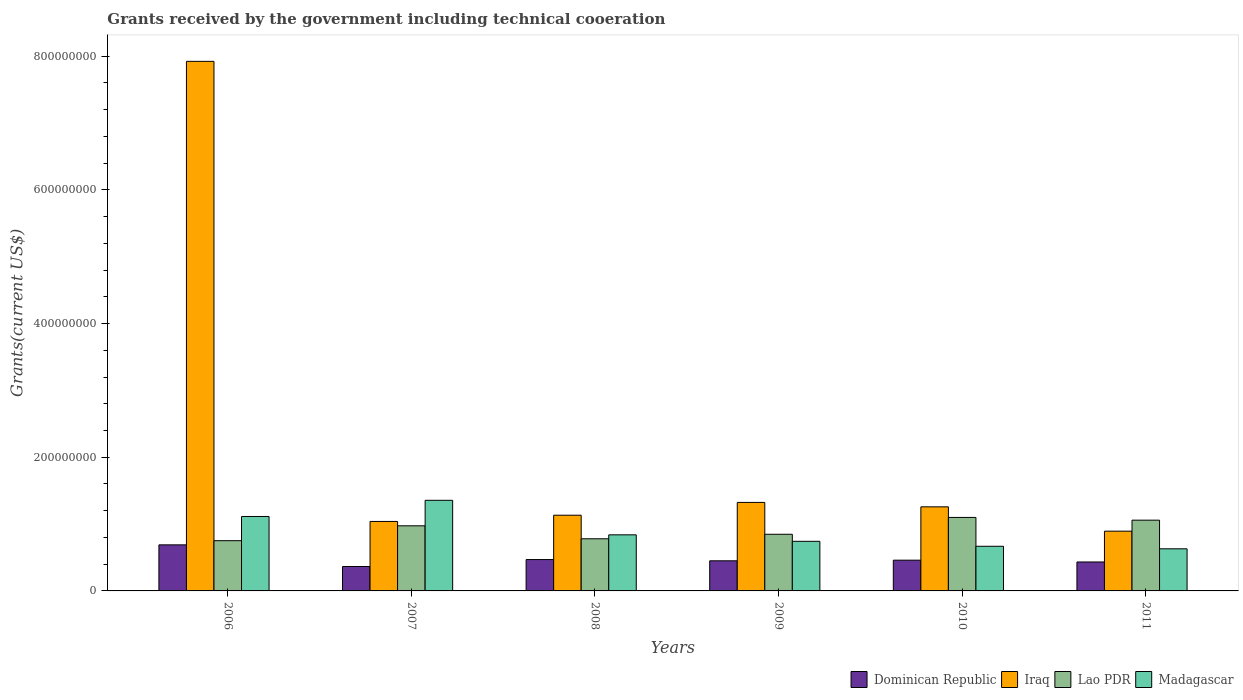How many different coloured bars are there?
Offer a very short reply. 4. Are the number of bars on each tick of the X-axis equal?
Provide a succinct answer. Yes. How many bars are there on the 4th tick from the left?
Your answer should be very brief. 4. What is the total grants received by the government in Lao PDR in 2010?
Your response must be concise. 1.10e+08. Across all years, what is the maximum total grants received by the government in Iraq?
Your answer should be compact. 7.92e+08. Across all years, what is the minimum total grants received by the government in Dominican Republic?
Ensure brevity in your answer.  3.65e+07. In which year was the total grants received by the government in Lao PDR maximum?
Your answer should be very brief. 2010. In which year was the total grants received by the government in Iraq minimum?
Ensure brevity in your answer.  2011. What is the total total grants received by the government in Madagascar in the graph?
Provide a succinct answer. 5.35e+08. What is the difference between the total grants received by the government in Madagascar in 2006 and that in 2009?
Your response must be concise. 3.72e+07. What is the difference between the total grants received by the government in Madagascar in 2011 and the total grants received by the government in Lao PDR in 2007?
Your answer should be very brief. -3.44e+07. What is the average total grants received by the government in Dominican Republic per year?
Provide a short and direct response. 4.78e+07. In the year 2006, what is the difference between the total grants received by the government in Iraq and total grants received by the government in Madagascar?
Ensure brevity in your answer.  6.81e+08. What is the ratio of the total grants received by the government in Lao PDR in 2006 to that in 2007?
Give a very brief answer. 0.77. Is the total grants received by the government in Lao PDR in 2008 less than that in 2009?
Make the answer very short. Yes. What is the difference between the highest and the second highest total grants received by the government in Madagascar?
Provide a short and direct response. 2.42e+07. What is the difference between the highest and the lowest total grants received by the government in Dominican Republic?
Ensure brevity in your answer.  3.24e+07. In how many years, is the total grants received by the government in Lao PDR greater than the average total grants received by the government in Lao PDR taken over all years?
Keep it short and to the point. 3. What does the 2nd bar from the left in 2007 represents?
Give a very brief answer. Iraq. What does the 2nd bar from the right in 2009 represents?
Provide a short and direct response. Lao PDR. Is it the case that in every year, the sum of the total grants received by the government in Lao PDR and total grants received by the government in Dominican Republic is greater than the total grants received by the government in Madagascar?
Ensure brevity in your answer.  No. How many bars are there?
Ensure brevity in your answer.  24. Are all the bars in the graph horizontal?
Provide a short and direct response. No. How many years are there in the graph?
Ensure brevity in your answer.  6. What is the difference between two consecutive major ticks on the Y-axis?
Provide a succinct answer. 2.00e+08. Does the graph contain grids?
Your answer should be very brief. No. Where does the legend appear in the graph?
Provide a succinct answer. Bottom right. What is the title of the graph?
Your answer should be very brief. Grants received by the government including technical cooeration. Does "Portugal" appear as one of the legend labels in the graph?
Your answer should be compact. No. What is the label or title of the X-axis?
Your answer should be compact. Years. What is the label or title of the Y-axis?
Offer a terse response. Grants(current US$). What is the Grants(current US$) of Dominican Republic in 2006?
Your answer should be very brief. 6.89e+07. What is the Grants(current US$) of Iraq in 2006?
Provide a short and direct response. 7.92e+08. What is the Grants(current US$) of Lao PDR in 2006?
Your response must be concise. 7.52e+07. What is the Grants(current US$) in Madagascar in 2006?
Provide a short and direct response. 1.11e+08. What is the Grants(current US$) in Dominican Republic in 2007?
Your response must be concise. 3.65e+07. What is the Grants(current US$) in Iraq in 2007?
Your answer should be very brief. 1.04e+08. What is the Grants(current US$) in Lao PDR in 2007?
Ensure brevity in your answer.  9.74e+07. What is the Grants(current US$) in Madagascar in 2007?
Provide a short and direct response. 1.36e+08. What is the Grants(current US$) in Dominican Republic in 2008?
Offer a very short reply. 4.69e+07. What is the Grants(current US$) in Iraq in 2008?
Make the answer very short. 1.13e+08. What is the Grants(current US$) of Lao PDR in 2008?
Provide a short and direct response. 7.80e+07. What is the Grants(current US$) of Madagascar in 2008?
Make the answer very short. 8.39e+07. What is the Grants(current US$) in Dominican Republic in 2009?
Provide a short and direct response. 4.51e+07. What is the Grants(current US$) in Iraq in 2009?
Your answer should be compact. 1.32e+08. What is the Grants(current US$) of Lao PDR in 2009?
Your answer should be very brief. 8.47e+07. What is the Grants(current US$) in Madagascar in 2009?
Provide a succinct answer. 7.42e+07. What is the Grants(current US$) of Dominican Republic in 2010?
Give a very brief answer. 4.60e+07. What is the Grants(current US$) in Iraq in 2010?
Offer a terse response. 1.26e+08. What is the Grants(current US$) of Lao PDR in 2010?
Keep it short and to the point. 1.10e+08. What is the Grants(current US$) of Madagascar in 2010?
Provide a succinct answer. 6.68e+07. What is the Grants(current US$) of Dominican Republic in 2011?
Your answer should be very brief. 4.33e+07. What is the Grants(current US$) in Iraq in 2011?
Provide a succinct answer. 8.94e+07. What is the Grants(current US$) of Lao PDR in 2011?
Your answer should be compact. 1.06e+08. What is the Grants(current US$) of Madagascar in 2011?
Give a very brief answer. 6.30e+07. Across all years, what is the maximum Grants(current US$) of Dominican Republic?
Give a very brief answer. 6.89e+07. Across all years, what is the maximum Grants(current US$) in Iraq?
Provide a short and direct response. 7.92e+08. Across all years, what is the maximum Grants(current US$) of Lao PDR?
Your answer should be very brief. 1.10e+08. Across all years, what is the maximum Grants(current US$) in Madagascar?
Provide a short and direct response. 1.36e+08. Across all years, what is the minimum Grants(current US$) of Dominican Republic?
Provide a short and direct response. 3.65e+07. Across all years, what is the minimum Grants(current US$) of Iraq?
Your answer should be very brief. 8.94e+07. Across all years, what is the minimum Grants(current US$) in Lao PDR?
Make the answer very short. 7.52e+07. Across all years, what is the minimum Grants(current US$) in Madagascar?
Offer a terse response. 6.30e+07. What is the total Grants(current US$) in Dominican Republic in the graph?
Your answer should be compact. 2.87e+08. What is the total Grants(current US$) in Iraq in the graph?
Offer a very short reply. 1.36e+09. What is the total Grants(current US$) in Lao PDR in the graph?
Ensure brevity in your answer.  5.51e+08. What is the total Grants(current US$) of Madagascar in the graph?
Your answer should be very brief. 5.35e+08. What is the difference between the Grants(current US$) of Dominican Republic in 2006 and that in 2007?
Your answer should be very brief. 3.24e+07. What is the difference between the Grants(current US$) of Iraq in 2006 and that in 2007?
Provide a succinct answer. 6.88e+08. What is the difference between the Grants(current US$) in Lao PDR in 2006 and that in 2007?
Your answer should be very brief. -2.22e+07. What is the difference between the Grants(current US$) of Madagascar in 2006 and that in 2007?
Give a very brief answer. -2.42e+07. What is the difference between the Grants(current US$) of Dominican Republic in 2006 and that in 2008?
Offer a very short reply. 2.20e+07. What is the difference between the Grants(current US$) in Iraq in 2006 and that in 2008?
Offer a very short reply. 6.79e+08. What is the difference between the Grants(current US$) in Lao PDR in 2006 and that in 2008?
Make the answer very short. -2.86e+06. What is the difference between the Grants(current US$) in Madagascar in 2006 and that in 2008?
Your answer should be compact. 2.75e+07. What is the difference between the Grants(current US$) in Dominican Republic in 2006 and that in 2009?
Your answer should be very brief. 2.38e+07. What is the difference between the Grants(current US$) of Iraq in 2006 and that in 2009?
Offer a very short reply. 6.60e+08. What is the difference between the Grants(current US$) of Lao PDR in 2006 and that in 2009?
Make the answer very short. -9.57e+06. What is the difference between the Grants(current US$) of Madagascar in 2006 and that in 2009?
Your response must be concise. 3.72e+07. What is the difference between the Grants(current US$) of Dominican Republic in 2006 and that in 2010?
Make the answer very short. 2.29e+07. What is the difference between the Grants(current US$) in Iraq in 2006 and that in 2010?
Keep it short and to the point. 6.66e+08. What is the difference between the Grants(current US$) of Lao PDR in 2006 and that in 2010?
Keep it short and to the point. -3.48e+07. What is the difference between the Grants(current US$) of Madagascar in 2006 and that in 2010?
Provide a succinct answer. 4.46e+07. What is the difference between the Grants(current US$) of Dominican Republic in 2006 and that in 2011?
Provide a short and direct response. 2.56e+07. What is the difference between the Grants(current US$) of Iraq in 2006 and that in 2011?
Offer a terse response. 7.03e+08. What is the difference between the Grants(current US$) in Lao PDR in 2006 and that in 2011?
Provide a short and direct response. -3.07e+07. What is the difference between the Grants(current US$) in Madagascar in 2006 and that in 2011?
Your response must be concise. 4.84e+07. What is the difference between the Grants(current US$) of Dominican Republic in 2007 and that in 2008?
Offer a very short reply. -1.04e+07. What is the difference between the Grants(current US$) of Iraq in 2007 and that in 2008?
Offer a very short reply. -9.33e+06. What is the difference between the Grants(current US$) in Lao PDR in 2007 and that in 2008?
Make the answer very short. 1.94e+07. What is the difference between the Grants(current US$) of Madagascar in 2007 and that in 2008?
Provide a succinct answer. 5.17e+07. What is the difference between the Grants(current US$) of Dominican Republic in 2007 and that in 2009?
Your answer should be very brief. -8.54e+06. What is the difference between the Grants(current US$) of Iraq in 2007 and that in 2009?
Offer a very short reply. -2.85e+07. What is the difference between the Grants(current US$) of Lao PDR in 2007 and that in 2009?
Provide a short and direct response. 1.27e+07. What is the difference between the Grants(current US$) of Madagascar in 2007 and that in 2009?
Make the answer very short. 6.14e+07. What is the difference between the Grants(current US$) of Dominican Republic in 2007 and that in 2010?
Offer a terse response. -9.47e+06. What is the difference between the Grants(current US$) of Iraq in 2007 and that in 2010?
Give a very brief answer. -2.19e+07. What is the difference between the Grants(current US$) in Lao PDR in 2007 and that in 2010?
Your answer should be compact. -1.26e+07. What is the difference between the Grants(current US$) in Madagascar in 2007 and that in 2010?
Give a very brief answer. 6.88e+07. What is the difference between the Grants(current US$) of Dominican Republic in 2007 and that in 2011?
Offer a very short reply. -6.79e+06. What is the difference between the Grants(current US$) of Iraq in 2007 and that in 2011?
Your response must be concise. 1.45e+07. What is the difference between the Grants(current US$) of Lao PDR in 2007 and that in 2011?
Give a very brief answer. -8.46e+06. What is the difference between the Grants(current US$) of Madagascar in 2007 and that in 2011?
Offer a very short reply. 7.26e+07. What is the difference between the Grants(current US$) of Dominican Republic in 2008 and that in 2009?
Provide a short and direct response. 1.86e+06. What is the difference between the Grants(current US$) in Iraq in 2008 and that in 2009?
Provide a short and direct response. -1.92e+07. What is the difference between the Grants(current US$) of Lao PDR in 2008 and that in 2009?
Give a very brief answer. -6.71e+06. What is the difference between the Grants(current US$) of Madagascar in 2008 and that in 2009?
Your answer should be compact. 9.69e+06. What is the difference between the Grants(current US$) of Dominican Republic in 2008 and that in 2010?
Offer a terse response. 9.30e+05. What is the difference between the Grants(current US$) in Iraq in 2008 and that in 2010?
Your response must be concise. -1.25e+07. What is the difference between the Grants(current US$) of Lao PDR in 2008 and that in 2010?
Your answer should be compact. -3.19e+07. What is the difference between the Grants(current US$) of Madagascar in 2008 and that in 2010?
Your answer should be compact. 1.71e+07. What is the difference between the Grants(current US$) of Dominican Republic in 2008 and that in 2011?
Provide a succinct answer. 3.61e+06. What is the difference between the Grants(current US$) in Iraq in 2008 and that in 2011?
Ensure brevity in your answer.  2.38e+07. What is the difference between the Grants(current US$) in Lao PDR in 2008 and that in 2011?
Give a very brief answer. -2.78e+07. What is the difference between the Grants(current US$) of Madagascar in 2008 and that in 2011?
Offer a terse response. 2.09e+07. What is the difference between the Grants(current US$) in Dominican Republic in 2009 and that in 2010?
Make the answer very short. -9.30e+05. What is the difference between the Grants(current US$) in Iraq in 2009 and that in 2010?
Offer a very short reply. 6.61e+06. What is the difference between the Grants(current US$) in Lao PDR in 2009 and that in 2010?
Provide a succinct answer. -2.52e+07. What is the difference between the Grants(current US$) in Madagascar in 2009 and that in 2010?
Provide a succinct answer. 7.41e+06. What is the difference between the Grants(current US$) in Dominican Republic in 2009 and that in 2011?
Your response must be concise. 1.75e+06. What is the difference between the Grants(current US$) of Iraq in 2009 and that in 2011?
Provide a succinct answer. 4.30e+07. What is the difference between the Grants(current US$) in Lao PDR in 2009 and that in 2011?
Ensure brevity in your answer.  -2.11e+07. What is the difference between the Grants(current US$) of Madagascar in 2009 and that in 2011?
Keep it short and to the point. 1.12e+07. What is the difference between the Grants(current US$) in Dominican Republic in 2010 and that in 2011?
Give a very brief answer. 2.68e+06. What is the difference between the Grants(current US$) in Iraq in 2010 and that in 2011?
Your answer should be very brief. 3.64e+07. What is the difference between the Grants(current US$) of Lao PDR in 2010 and that in 2011?
Offer a terse response. 4.09e+06. What is the difference between the Grants(current US$) in Madagascar in 2010 and that in 2011?
Provide a short and direct response. 3.79e+06. What is the difference between the Grants(current US$) in Dominican Republic in 2006 and the Grants(current US$) in Iraq in 2007?
Offer a terse response. -3.50e+07. What is the difference between the Grants(current US$) of Dominican Republic in 2006 and the Grants(current US$) of Lao PDR in 2007?
Your answer should be compact. -2.85e+07. What is the difference between the Grants(current US$) in Dominican Republic in 2006 and the Grants(current US$) in Madagascar in 2007?
Give a very brief answer. -6.66e+07. What is the difference between the Grants(current US$) in Iraq in 2006 and the Grants(current US$) in Lao PDR in 2007?
Make the answer very short. 6.95e+08. What is the difference between the Grants(current US$) in Iraq in 2006 and the Grants(current US$) in Madagascar in 2007?
Your response must be concise. 6.57e+08. What is the difference between the Grants(current US$) in Lao PDR in 2006 and the Grants(current US$) in Madagascar in 2007?
Your answer should be very brief. -6.04e+07. What is the difference between the Grants(current US$) of Dominican Republic in 2006 and the Grants(current US$) of Iraq in 2008?
Provide a succinct answer. -4.43e+07. What is the difference between the Grants(current US$) in Dominican Republic in 2006 and the Grants(current US$) in Lao PDR in 2008?
Your response must be concise. -9.11e+06. What is the difference between the Grants(current US$) of Dominican Republic in 2006 and the Grants(current US$) of Madagascar in 2008?
Make the answer very short. -1.50e+07. What is the difference between the Grants(current US$) in Iraq in 2006 and the Grants(current US$) in Lao PDR in 2008?
Offer a terse response. 7.14e+08. What is the difference between the Grants(current US$) in Iraq in 2006 and the Grants(current US$) in Madagascar in 2008?
Provide a succinct answer. 7.08e+08. What is the difference between the Grants(current US$) in Lao PDR in 2006 and the Grants(current US$) in Madagascar in 2008?
Make the answer very short. -8.73e+06. What is the difference between the Grants(current US$) in Dominican Republic in 2006 and the Grants(current US$) in Iraq in 2009?
Offer a very short reply. -6.35e+07. What is the difference between the Grants(current US$) of Dominican Republic in 2006 and the Grants(current US$) of Lao PDR in 2009?
Your answer should be very brief. -1.58e+07. What is the difference between the Grants(current US$) of Dominican Republic in 2006 and the Grants(current US$) of Madagascar in 2009?
Offer a terse response. -5.29e+06. What is the difference between the Grants(current US$) of Iraq in 2006 and the Grants(current US$) of Lao PDR in 2009?
Keep it short and to the point. 7.07e+08. What is the difference between the Grants(current US$) in Iraq in 2006 and the Grants(current US$) in Madagascar in 2009?
Your response must be concise. 7.18e+08. What is the difference between the Grants(current US$) in Lao PDR in 2006 and the Grants(current US$) in Madagascar in 2009?
Your answer should be compact. 9.60e+05. What is the difference between the Grants(current US$) in Dominican Republic in 2006 and the Grants(current US$) in Iraq in 2010?
Your response must be concise. -5.69e+07. What is the difference between the Grants(current US$) in Dominican Republic in 2006 and the Grants(current US$) in Lao PDR in 2010?
Give a very brief answer. -4.10e+07. What is the difference between the Grants(current US$) in Dominican Republic in 2006 and the Grants(current US$) in Madagascar in 2010?
Offer a terse response. 2.12e+06. What is the difference between the Grants(current US$) of Iraq in 2006 and the Grants(current US$) of Lao PDR in 2010?
Your answer should be very brief. 6.82e+08. What is the difference between the Grants(current US$) of Iraq in 2006 and the Grants(current US$) of Madagascar in 2010?
Your response must be concise. 7.25e+08. What is the difference between the Grants(current US$) in Lao PDR in 2006 and the Grants(current US$) in Madagascar in 2010?
Your answer should be compact. 8.37e+06. What is the difference between the Grants(current US$) in Dominican Republic in 2006 and the Grants(current US$) in Iraq in 2011?
Provide a succinct answer. -2.05e+07. What is the difference between the Grants(current US$) in Dominican Republic in 2006 and the Grants(current US$) in Lao PDR in 2011?
Your response must be concise. -3.70e+07. What is the difference between the Grants(current US$) of Dominican Republic in 2006 and the Grants(current US$) of Madagascar in 2011?
Ensure brevity in your answer.  5.91e+06. What is the difference between the Grants(current US$) in Iraq in 2006 and the Grants(current US$) in Lao PDR in 2011?
Give a very brief answer. 6.86e+08. What is the difference between the Grants(current US$) in Iraq in 2006 and the Grants(current US$) in Madagascar in 2011?
Give a very brief answer. 7.29e+08. What is the difference between the Grants(current US$) in Lao PDR in 2006 and the Grants(current US$) in Madagascar in 2011?
Offer a terse response. 1.22e+07. What is the difference between the Grants(current US$) in Dominican Republic in 2007 and the Grants(current US$) in Iraq in 2008?
Keep it short and to the point. -7.67e+07. What is the difference between the Grants(current US$) in Dominican Republic in 2007 and the Grants(current US$) in Lao PDR in 2008?
Give a very brief answer. -4.15e+07. What is the difference between the Grants(current US$) of Dominican Republic in 2007 and the Grants(current US$) of Madagascar in 2008?
Provide a succinct answer. -4.74e+07. What is the difference between the Grants(current US$) in Iraq in 2007 and the Grants(current US$) in Lao PDR in 2008?
Provide a succinct answer. 2.59e+07. What is the difference between the Grants(current US$) of Iraq in 2007 and the Grants(current US$) of Madagascar in 2008?
Make the answer very short. 2.00e+07. What is the difference between the Grants(current US$) in Lao PDR in 2007 and the Grants(current US$) in Madagascar in 2008?
Give a very brief answer. 1.35e+07. What is the difference between the Grants(current US$) of Dominican Republic in 2007 and the Grants(current US$) of Iraq in 2009?
Make the answer very short. -9.59e+07. What is the difference between the Grants(current US$) of Dominican Republic in 2007 and the Grants(current US$) of Lao PDR in 2009?
Your response must be concise. -4.82e+07. What is the difference between the Grants(current US$) of Dominican Republic in 2007 and the Grants(current US$) of Madagascar in 2009?
Your answer should be compact. -3.77e+07. What is the difference between the Grants(current US$) in Iraq in 2007 and the Grants(current US$) in Lao PDR in 2009?
Your answer should be compact. 1.92e+07. What is the difference between the Grants(current US$) of Iraq in 2007 and the Grants(current US$) of Madagascar in 2009?
Make the answer very short. 2.97e+07. What is the difference between the Grants(current US$) of Lao PDR in 2007 and the Grants(current US$) of Madagascar in 2009?
Offer a terse response. 2.32e+07. What is the difference between the Grants(current US$) of Dominican Republic in 2007 and the Grants(current US$) of Iraq in 2010?
Provide a short and direct response. -8.93e+07. What is the difference between the Grants(current US$) in Dominican Republic in 2007 and the Grants(current US$) in Lao PDR in 2010?
Keep it short and to the point. -7.34e+07. What is the difference between the Grants(current US$) in Dominican Republic in 2007 and the Grants(current US$) in Madagascar in 2010?
Offer a terse response. -3.03e+07. What is the difference between the Grants(current US$) of Iraq in 2007 and the Grants(current US$) of Lao PDR in 2010?
Your answer should be very brief. -6.03e+06. What is the difference between the Grants(current US$) of Iraq in 2007 and the Grants(current US$) of Madagascar in 2010?
Keep it short and to the point. 3.71e+07. What is the difference between the Grants(current US$) of Lao PDR in 2007 and the Grants(current US$) of Madagascar in 2010?
Provide a succinct answer. 3.06e+07. What is the difference between the Grants(current US$) in Dominican Republic in 2007 and the Grants(current US$) in Iraq in 2011?
Give a very brief answer. -5.29e+07. What is the difference between the Grants(current US$) of Dominican Republic in 2007 and the Grants(current US$) of Lao PDR in 2011?
Make the answer very short. -6.93e+07. What is the difference between the Grants(current US$) in Dominican Republic in 2007 and the Grants(current US$) in Madagascar in 2011?
Your answer should be compact. -2.65e+07. What is the difference between the Grants(current US$) in Iraq in 2007 and the Grants(current US$) in Lao PDR in 2011?
Offer a very short reply. -1.94e+06. What is the difference between the Grants(current US$) of Iraq in 2007 and the Grants(current US$) of Madagascar in 2011?
Make the answer very short. 4.09e+07. What is the difference between the Grants(current US$) of Lao PDR in 2007 and the Grants(current US$) of Madagascar in 2011?
Your response must be concise. 3.44e+07. What is the difference between the Grants(current US$) in Dominican Republic in 2008 and the Grants(current US$) in Iraq in 2009?
Make the answer very short. -8.55e+07. What is the difference between the Grants(current US$) in Dominican Republic in 2008 and the Grants(current US$) in Lao PDR in 2009?
Provide a succinct answer. -3.78e+07. What is the difference between the Grants(current US$) of Dominican Republic in 2008 and the Grants(current US$) of Madagascar in 2009?
Give a very brief answer. -2.73e+07. What is the difference between the Grants(current US$) of Iraq in 2008 and the Grants(current US$) of Lao PDR in 2009?
Give a very brief answer. 2.85e+07. What is the difference between the Grants(current US$) of Iraq in 2008 and the Grants(current US$) of Madagascar in 2009?
Provide a succinct answer. 3.90e+07. What is the difference between the Grants(current US$) in Lao PDR in 2008 and the Grants(current US$) in Madagascar in 2009?
Give a very brief answer. 3.82e+06. What is the difference between the Grants(current US$) in Dominican Republic in 2008 and the Grants(current US$) in Iraq in 2010?
Your answer should be very brief. -7.89e+07. What is the difference between the Grants(current US$) of Dominican Republic in 2008 and the Grants(current US$) of Lao PDR in 2010?
Offer a terse response. -6.30e+07. What is the difference between the Grants(current US$) in Dominican Republic in 2008 and the Grants(current US$) in Madagascar in 2010?
Your response must be concise. -1.99e+07. What is the difference between the Grants(current US$) of Iraq in 2008 and the Grants(current US$) of Lao PDR in 2010?
Make the answer very short. 3.30e+06. What is the difference between the Grants(current US$) in Iraq in 2008 and the Grants(current US$) in Madagascar in 2010?
Your response must be concise. 4.65e+07. What is the difference between the Grants(current US$) of Lao PDR in 2008 and the Grants(current US$) of Madagascar in 2010?
Your response must be concise. 1.12e+07. What is the difference between the Grants(current US$) of Dominican Republic in 2008 and the Grants(current US$) of Iraq in 2011?
Offer a terse response. -4.25e+07. What is the difference between the Grants(current US$) of Dominican Republic in 2008 and the Grants(current US$) of Lao PDR in 2011?
Your response must be concise. -5.89e+07. What is the difference between the Grants(current US$) in Dominican Republic in 2008 and the Grants(current US$) in Madagascar in 2011?
Give a very brief answer. -1.61e+07. What is the difference between the Grants(current US$) in Iraq in 2008 and the Grants(current US$) in Lao PDR in 2011?
Offer a very short reply. 7.39e+06. What is the difference between the Grants(current US$) of Iraq in 2008 and the Grants(current US$) of Madagascar in 2011?
Your answer should be compact. 5.02e+07. What is the difference between the Grants(current US$) of Lao PDR in 2008 and the Grants(current US$) of Madagascar in 2011?
Keep it short and to the point. 1.50e+07. What is the difference between the Grants(current US$) of Dominican Republic in 2009 and the Grants(current US$) of Iraq in 2010?
Your answer should be compact. -8.07e+07. What is the difference between the Grants(current US$) of Dominican Republic in 2009 and the Grants(current US$) of Lao PDR in 2010?
Your answer should be compact. -6.49e+07. What is the difference between the Grants(current US$) in Dominican Republic in 2009 and the Grants(current US$) in Madagascar in 2010?
Make the answer very short. -2.17e+07. What is the difference between the Grants(current US$) in Iraq in 2009 and the Grants(current US$) in Lao PDR in 2010?
Offer a terse response. 2.24e+07. What is the difference between the Grants(current US$) in Iraq in 2009 and the Grants(current US$) in Madagascar in 2010?
Offer a terse response. 6.56e+07. What is the difference between the Grants(current US$) of Lao PDR in 2009 and the Grants(current US$) of Madagascar in 2010?
Offer a very short reply. 1.79e+07. What is the difference between the Grants(current US$) of Dominican Republic in 2009 and the Grants(current US$) of Iraq in 2011?
Offer a terse response. -4.43e+07. What is the difference between the Grants(current US$) of Dominican Republic in 2009 and the Grants(current US$) of Lao PDR in 2011?
Your answer should be compact. -6.08e+07. What is the difference between the Grants(current US$) in Dominican Republic in 2009 and the Grants(current US$) in Madagascar in 2011?
Offer a terse response. -1.79e+07. What is the difference between the Grants(current US$) in Iraq in 2009 and the Grants(current US$) in Lao PDR in 2011?
Your response must be concise. 2.65e+07. What is the difference between the Grants(current US$) in Iraq in 2009 and the Grants(current US$) in Madagascar in 2011?
Give a very brief answer. 6.94e+07. What is the difference between the Grants(current US$) in Lao PDR in 2009 and the Grants(current US$) in Madagascar in 2011?
Your answer should be very brief. 2.17e+07. What is the difference between the Grants(current US$) of Dominican Republic in 2010 and the Grants(current US$) of Iraq in 2011?
Give a very brief answer. -4.34e+07. What is the difference between the Grants(current US$) in Dominican Republic in 2010 and the Grants(current US$) in Lao PDR in 2011?
Make the answer very short. -5.99e+07. What is the difference between the Grants(current US$) of Dominican Republic in 2010 and the Grants(current US$) of Madagascar in 2011?
Provide a short and direct response. -1.70e+07. What is the difference between the Grants(current US$) in Iraq in 2010 and the Grants(current US$) in Lao PDR in 2011?
Make the answer very short. 1.99e+07. What is the difference between the Grants(current US$) in Iraq in 2010 and the Grants(current US$) in Madagascar in 2011?
Keep it short and to the point. 6.28e+07. What is the difference between the Grants(current US$) in Lao PDR in 2010 and the Grants(current US$) in Madagascar in 2011?
Your answer should be very brief. 4.70e+07. What is the average Grants(current US$) of Dominican Republic per year?
Keep it short and to the point. 4.78e+07. What is the average Grants(current US$) of Iraq per year?
Offer a terse response. 2.26e+08. What is the average Grants(current US$) of Lao PDR per year?
Your answer should be compact. 9.19e+07. What is the average Grants(current US$) of Madagascar per year?
Your response must be concise. 8.91e+07. In the year 2006, what is the difference between the Grants(current US$) in Dominican Republic and Grants(current US$) in Iraq?
Provide a short and direct response. -7.23e+08. In the year 2006, what is the difference between the Grants(current US$) in Dominican Republic and Grants(current US$) in Lao PDR?
Provide a succinct answer. -6.25e+06. In the year 2006, what is the difference between the Grants(current US$) in Dominican Republic and Grants(current US$) in Madagascar?
Your response must be concise. -4.25e+07. In the year 2006, what is the difference between the Grants(current US$) of Iraq and Grants(current US$) of Lao PDR?
Your answer should be very brief. 7.17e+08. In the year 2006, what is the difference between the Grants(current US$) in Iraq and Grants(current US$) in Madagascar?
Provide a short and direct response. 6.81e+08. In the year 2006, what is the difference between the Grants(current US$) in Lao PDR and Grants(current US$) in Madagascar?
Keep it short and to the point. -3.62e+07. In the year 2007, what is the difference between the Grants(current US$) in Dominican Republic and Grants(current US$) in Iraq?
Keep it short and to the point. -6.74e+07. In the year 2007, what is the difference between the Grants(current US$) of Dominican Republic and Grants(current US$) of Lao PDR?
Provide a succinct answer. -6.09e+07. In the year 2007, what is the difference between the Grants(current US$) of Dominican Republic and Grants(current US$) of Madagascar?
Offer a very short reply. -9.90e+07. In the year 2007, what is the difference between the Grants(current US$) of Iraq and Grants(current US$) of Lao PDR?
Your response must be concise. 6.52e+06. In the year 2007, what is the difference between the Grants(current US$) in Iraq and Grants(current US$) in Madagascar?
Provide a short and direct response. -3.16e+07. In the year 2007, what is the difference between the Grants(current US$) of Lao PDR and Grants(current US$) of Madagascar?
Ensure brevity in your answer.  -3.82e+07. In the year 2008, what is the difference between the Grants(current US$) in Dominican Republic and Grants(current US$) in Iraq?
Your response must be concise. -6.63e+07. In the year 2008, what is the difference between the Grants(current US$) of Dominican Republic and Grants(current US$) of Lao PDR?
Ensure brevity in your answer.  -3.11e+07. In the year 2008, what is the difference between the Grants(current US$) of Dominican Republic and Grants(current US$) of Madagascar?
Ensure brevity in your answer.  -3.70e+07. In the year 2008, what is the difference between the Grants(current US$) in Iraq and Grants(current US$) in Lao PDR?
Provide a succinct answer. 3.52e+07. In the year 2008, what is the difference between the Grants(current US$) in Iraq and Grants(current US$) in Madagascar?
Provide a succinct answer. 2.94e+07. In the year 2008, what is the difference between the Grants(current US$) in Lao PDR and Grants(current US$) in Madagascar?
Your answer should be compact. -5.87e+06. In the year 2009, what is the difference between the Grants(current US$) in Dominican Republic and Grants(current US$) in Iraq?
Provide a short and direct response. -8.73e+07. In the year 2009, what is the difference between the Grants(current US$) of Dominican Republic and Grants(current US$) of Lao PDR?
Offer a very short reply. -3.97e+07. In the year 2009, what is the difference between the Grants(current US$) in Dominican Republic and Grants(current US$) in Madagascar?
Give a very brief answer. -2.91e+07. In the year 2009, what is the difference between the Grants(current US$) in Iraq and Grants(current US$) in Lao PDR?
Provide a short and direct response. 4.77e+07. In the year 2009, what is the difference between the Grants(current US$) of Iraq and Grants(current US$) of Madagascar?
Make the answer very short. 5.82e+07. In the year 2009, what is the difference between the Grants(current US$) in Lao PDR and Grants(current US$) in Madagascar?
Provide a short and direct response. 1.05e+07. In the year 2010, what is the difference between the Grants(current US$) of Dominican Republic and Grants(current US$) of Iraq?
Your response must be concise. -7.98e+07. In the year 2010, what is the difference between the Grants(current US$) of Dominican Republic and Grants(current US$) of Lao PDR?
Make the answer very short. -6.40e+07. In the year 2010, what is the difference between the Grants(current US$) in Dominican Republic and Grants(current US$) in Madagascar?
Provide a short and direct response. -2.08e+07. In the year 2010, what is the difference between the Grants(current US$) of Iraq and Grants(current US$) of Lao PDR?
Your answer should be very brief. 1.58e+07. In the year 2010, what is the difference between the Grants(current US$) in Iraq and Grants(current US$) in Madagascar?
Offer a very short reply. 5.90e+07. In the year 2010, what is the difference between the Grants(current US$) in Lao PDR and Grants(current US$) in Madagascar?
Provide a succinct answer. 4.32e+07. In the year 2011, what is the difference between the Grants(current US$) in Dominican Republic and Grants(current US$) in Iraq?
Your answer should be compact. -4.61e+07. In the year 2011, what is the difference between the Grants(current US$) of Dominican Republic and Grants(current US$) of Lao PDR?
Your answer should be very brief. -6.26e+07. In the year 2011, what is the difference between the Grants(current US$) of Dominican Republic and Grants(current US$) of Madagascar?
Give a very brief answer. -1.97e+07. In the year 2011, what is the difference between the Grants(current US$) of Iraq and Grants(current US$) of Lao PDR?
Offer a terse response. -1.65e+07. In the year 2011, what is the difference between the Grants(current US$) in Iraq and Grants(current US$) in Madagascar?
Keep it short and to the point. 2.64e+07. In the year 2011, what is the difference between the Grants(current US$) in Lao PDR and Grants(current US$) in Madagascar?
Provide a short and direct response. 4.29e+07. What is the ratio of the Grants(current US$) of Dominican Republic in 2006 to that in 2007?
Offer a very short reply. 1.89. What is the ratio of the Grants(current US$) in Iraq in 2006 to that in 2007?
Your answer should be very brief. 7.62. What is the ratio of the Grants(current US$) of Lao PDR in 2006 to that in 2007?
Your response must be concise. 0.77. What is the ratio of the Grants(current US$) in Madagascar in 2006 to that in 2007?
Your answer should be compact. 0.82. What is the ratio of the Grants(current US$) of Dominican Republic in 2006 to that in 2008?
Your response must be concise. 1.47. What is the ratio of the Grants(current US$) in Iraq in 2006 to that in 2008?
Offer a very short reply. 7. What is the ratio of the Grants(current US$) in Lao PDR in 2006 to that in 2008?
Give a very brief answer. 0.96. What is the ratio of the Grants(current US$) of Madagascar in 2006 to that in 2008?
Provide a succinct answer. 1.33. What is the ratio of the Grants(current US$) of Dominican Republic in 2006 to that in 2009?
Your answer should be very brief. 1.53. What is the ratio of the Grants(current US$) of Iraq in 2006 to that in 2009?
Your answer should be compact. 5.98. What is the ratio of the Grants(current US$) of Lao PDR in 2006 to that in 2009?
Make the answer very short. 0.89. What is the ratio of the Grants(current US$) in Madagascar in 2006 to that in 2009?
Offer a very short reply. 1.5. What is the ratio of the Grants(current US$) in Dominican Republic in 2006 to that in 2010?
Offer a terse response. 1.5. What is the ratio of the Grants(current US$) of Iraq in 2006 to that in 2010?
Keep it short and to the point. 6.3. What is the ratio of the Grants(current US$) in Lao PDR in 2006 to that in 2010?
Your answer should be very brief. 0.68. What is the ratio of the Grants(current US$) of Madagascar in 2006 to that in 2010?
Your response must be concise. 1.67. What is the ratio of the Grants(current US$) in Dominican Republic in 2006 to that in 2011?
Offer a terse response. 1.59. What is the ratio of the Grants(current US$) in Iraq in 2006 to that in 2011?
Ensure brevity in your answer.  8.86. What is the ratio of the Grants(current US$) of Lao PDR in 2006 to that in 2011?
Your response must be concise. 0.71. What is the ratio of the Grants(current US$) of Madagascar in 2006 to that in 2011?
Your answer should be compact. 1.77. What is the ratio of the Grants(current US$) in Dominican Republic in 2007 to that in 2008?
Provide a short and direct response. 0.78. What is the ratio of the Grants(current US$) in Iraq in 2007 to that in 2008?
Your answer should be very brief. 0.92. What is the ratio of the Grants(current US$) in Lao PDR in 2007 to that in 2008?
Your answer should be very brief. 1.25. What is the ratio of the Grants(current US$) of Madagascar in 2007 to that in 2008?
Offer a very short reply. 1.62. What is the ratio of the Grants(current US$) in Dominican Republic in 2007 to that in 2009?
Your answer should be very brief. 0.81. What is the ratio of the Grants(current US$) in Iraq in 2007 to that in 2009?
Your answer should be compact. 0.78. What is the ratio of the Grants(current US$) in Lao PDR in 2007 to that in 2009?
Make the answer very short. 1.15. What is the ratio of the Grants(current US$) in Madagascar in 2007 to that in 2009?
Keep it short and to the point. 1.83. What is the ratio of the Grants(current US$) in Dominican Republic in 2007 to that in 2010?
Provide a short and direct response. 0.79. What is the ratio of the Grants(current US$) in Iraq in 2007 to that in 2010?
Provide a succinct answer. 0.83. What is the ratio of the Grants(current US$) in Lao PDR in 2007 to that in 2010?
Give a very brief answer. 0.89. What is the ratio of the Grants(current US$) in Madagascar in 2007 to that in 2010?
Give a very brief answer. 2.03. What is the ratio of the Grants(current US$) in Dominican Republic in 2007 to that in 2011?
Your response must be concise. 0.84. What is the ratio of the Grants(current US$) in Iraq in 2007 to that in 2011?
Your answer should be very brief. 1.16. What is the ratio of the Grants(current US$) in Lao PDR in 2007 to that in 2011?
Keep it short and to the point. 0.92. What is the ratio of the Grants(current US$) in Madagascar in 2007 to that in 2011?
Make the answer very short. 2.15. What is the ratio of the Grants(current US$) of Dominican Republic in 2008 to that in 2009?
Keep it short and to the point. 1.04. What is the ratio of the Grants(current US$) in Iraq in 2008 to that in 2009?
Provide a short and direct response. 0.86. What is the ratio of the Grants(current US$) of Lao PDR in 2008 to that in 2009?
Make the answer very short. 0.92. What is the ratio of the Grants(current US$) in Madagascar in 2008 to that in 2009?
Keep it short and to the point. 1.13. What is the ratio of the Grants(current US$) of Dominican Republic in 2008 to that in 2010?
Offer a terse response. 1.02. What is the ratio of the Grants(current US$) of Iraq in 2008 to that in 2010?
Give a very brief answer. 0.9. What is the ratio of the Grants(current US$) in Lao PDR in 2008 to that in 2010?
Provide a succinct answer. 0.71. What is the ratio of the Grants(current US$) in Madagascar in 2008 to that in 2010?
Your response must be concise. 1.26. What is the ratio of the Grants(current US$) in Dominican Republic in 2008 to that in 2011?
Ensure brevity in your answer.  1.08. What is the ratio of the Grants(current US$) in Iraq in 2008 to that in 2011?
Offer a terse response. 1.27. What is the ratio of the Grants(current US$) of Lao PDR in 2008 to that in 2011?
Provide a short and direct response. 0.74. What is the ratio of the Grants(current US$) in Madagascar in 2008 to that in 2011?
Your answer should be very brief. 1.33. What is the ratio of the Grants(current US$) of Dominican Republic in 2009 to that in 2010?
Your response must be concise. 0.98. What is the ratio of the Grants(current US$) of Iraq in 2009 to that in 2010?
Offer a terse response. 1.05. What is the ratio of the Grants(current US$) in Lao PDR in 2009 to that in 2010?
Make the answer very short. 0.77. What is the ratio of the Grants(current US$) of Madagascar in 2009 to that in 2010?
Offer a very short reply. 1.11. What is the ratio of the Grants(current US$) of Dominican Republic in 2009 to that in 2011?
Offer a very short reply. 1.04. What is the ratio of the Grants(current US$) of Iraq in 2009 to that in 2011?
Your response must be concise. 1.48. What is the ratio of the Grants(current US$) of Lao PDR in 2009 to that in 2011?
Your response must be concise. 0.8. What is the ratio of the Grants(current US$) in Madagascar in 2009 to that in 2011?
Make the answer very short. 1.18. What is the ratio of the Grants(current US$) of Dominican Republic in 2010 to that in 2011?
Provide a succinct answer. 1.06. What is the ratio of the Grants(current US$) of Iraq in 2010 to that in 2011?
Offer a very short reply. 1.41. What is the ratio of the Grants(current US$) of Lao PDR in 2010 to that in 2011?
Make the answer very short. 1.04. What is the ratio of the Grants(current US$) in Madagascar in 2010 to that in 2011?
Ensure brevity in your answer.  1.06. What is the difference between the highest and the second highest Grants(current US$) in Dominican Republic?
Make the answer very short. 2.20e+07. What is the difference between the highest and the second highest Grants(current US$) of Iraq?
Offer a terse response. 6.60e+08. What is the difference between the highest and the second highest Grants(current US$) of Lao PDR?
Give a very brief answer. 4.09e+06. What is the difference between the highest and the second highest Grants(current US$) in Madagascar?
Provide a succinct answer. 2.42e+07. What is the difference between the highest and the lowest Grants(current US$) in Dominican Republic?
Provide a succinct answer. 3.24e+07. What is the difference between the highest and the lowest Grants(current US$) of Iraq?
Provide a succinct answer. 7.03e+08. What is the difference between the highest and the lowest Grants(current US$) in Lao PDR?
Your answer should be compact. 3.48e+07. What is the difference between the highest and the lowest Grants(current US$) of Madagascar?
Offer a terse response. 7.26e+07. 